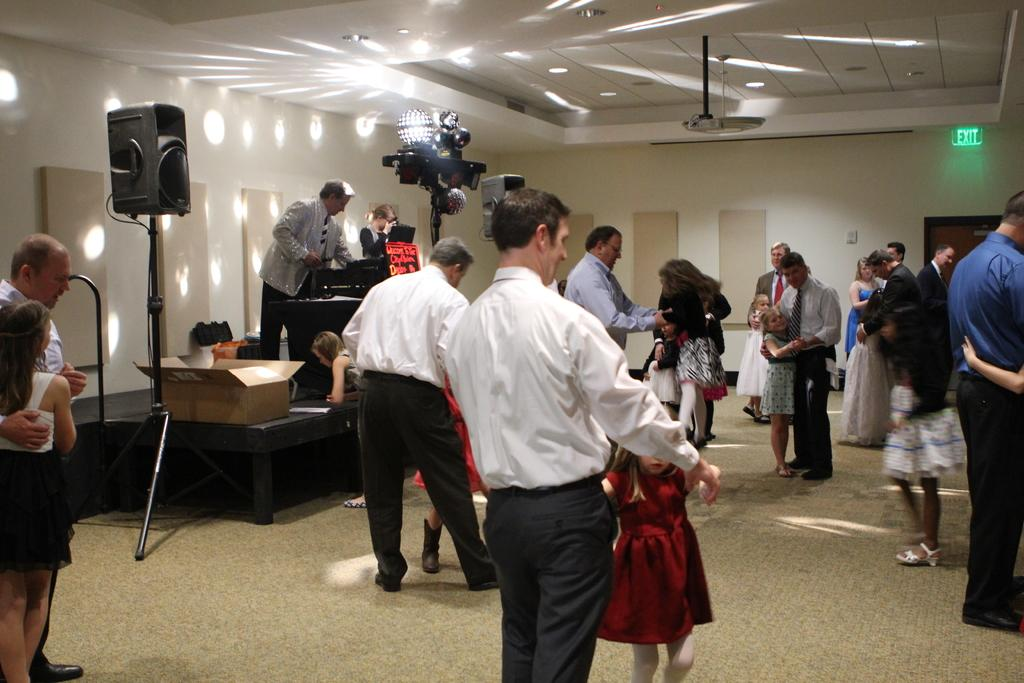How many people are in the image? There is a group of people standing in the image, but the exact number cannot be determined from the provided facts. Where are the people standing in the image? The people are standing on the floor in the image. What type of lighting is present in the room? There are lights on the ceiling and walls in the image. What is the box in the image used for? The purpose of the box in the image cannot be determined from the provided facts. What other objects are present in the room? There are other objects in the image, but their specific nature cannot be determined from the provided facts. What type of room is depicted in the image? The image is an inside view of a room. What type of soup is being served in the image? There is no soup present in the image. Can you tell me how many dogs are in the image? There are no dogs present in the image. 